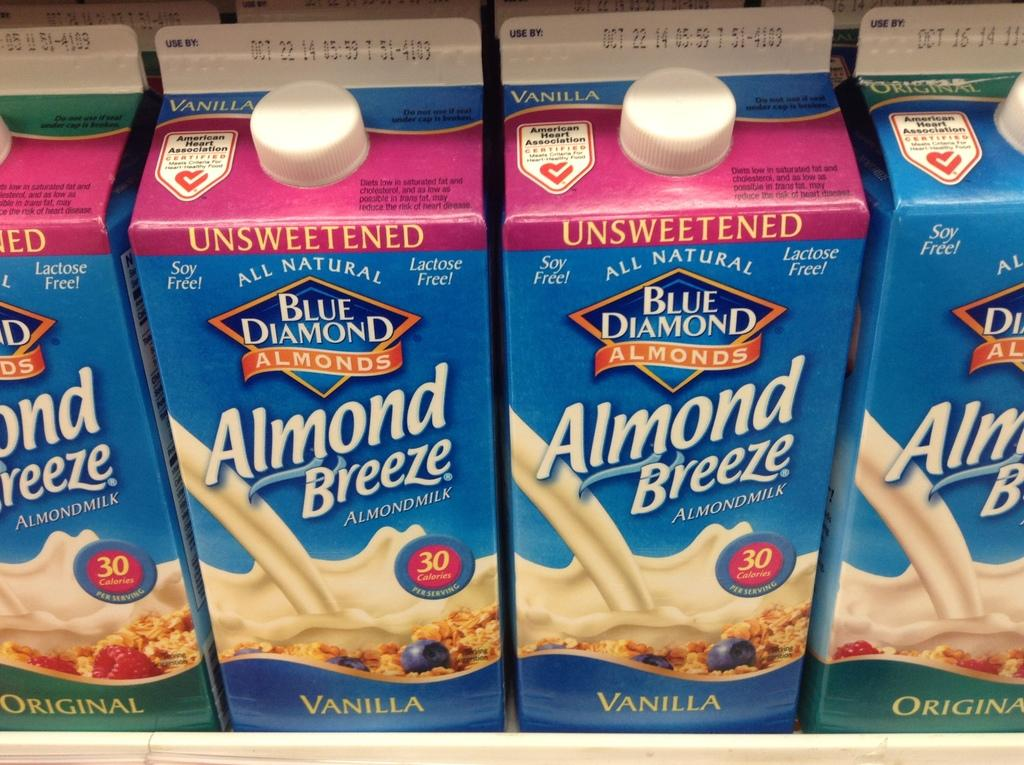What type of bottles are depicted in the image? There are paper bottles in the image. What feature do the paper bottles have? The paper bottles have lids. What grade does the station receive for its recycling efforts in the image? There is no mention of a station or recycling efforts in the image, so it is not possible to answer this question. 